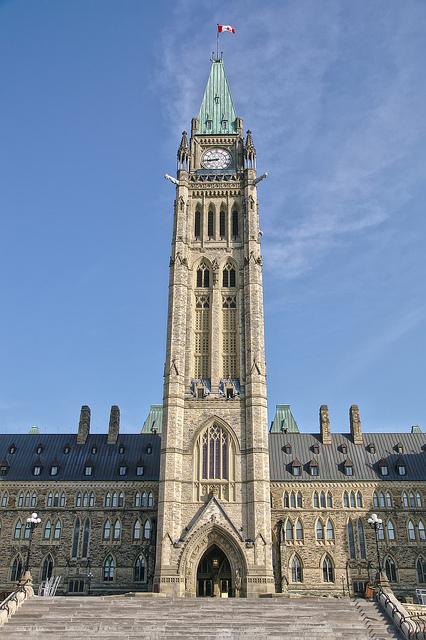What is on the very top of this building?
Answer briefly. Flag. Is this a government building?
Be succinct. Yes. What season is this?
Quick response, please. Summer. Do you see any street lights?
Short answer required. No. Where was the photograph taken of the tower with a clock?
Concise answer only. London. What is at the top of the tower?
Give a very brief answer. Flag. What season was this photo taken?
Be succinct. Summer. Are there many clouds in the sky?
Short answer required. No. How many buildings do you see?
Write a very short answer. 1. 